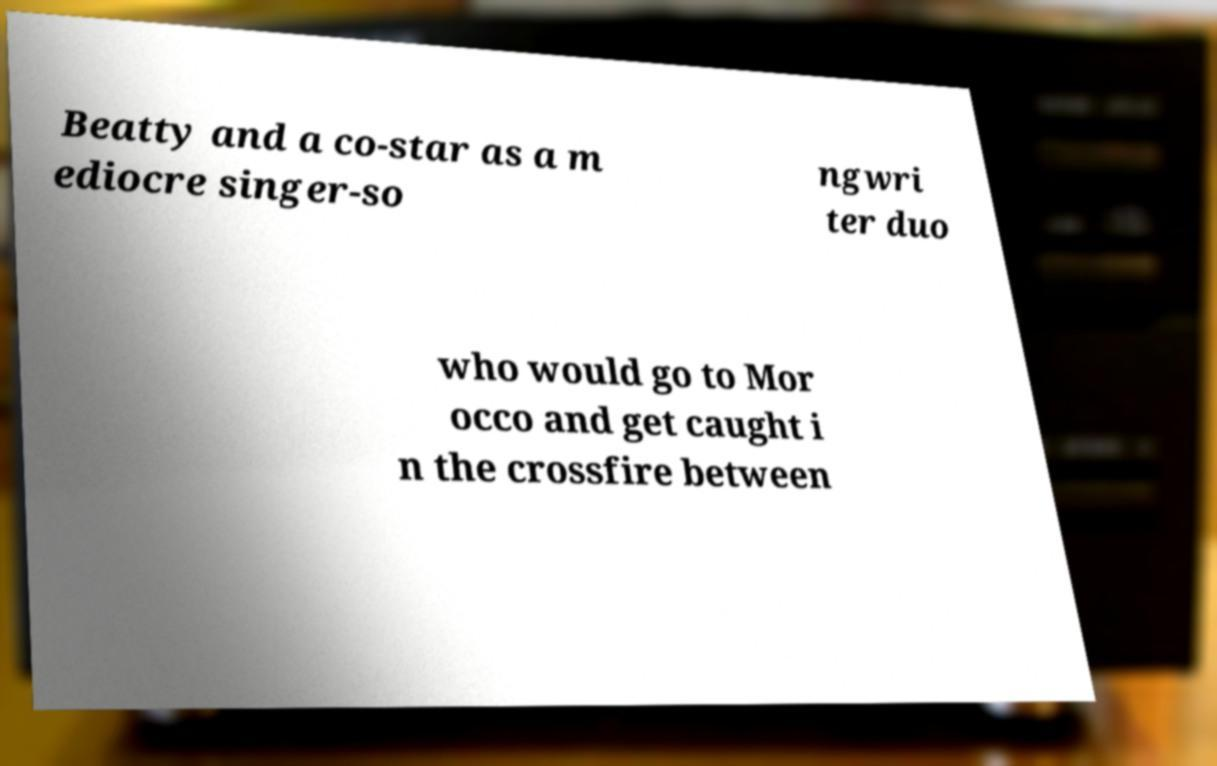Could you assist in decoding the text presented in this image and type it out clearly? Beatty and a co-star as a m ediocre singer-so ngwri ter duo who would go to Mor occo and get caught i n the crossfire between 